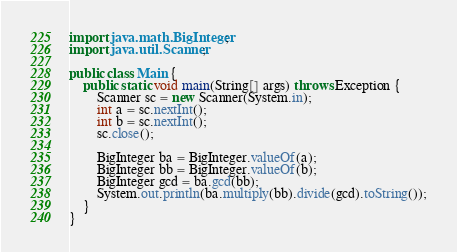Convert code to text. <code><loc_0><loc_0><loc_500><loc_500><_Java_>import java.math.BigInteger;
import java.util.Scanner;

public class Main {
	public static void main(String[] args) throws Exception {
		Scanner sc = new Scanner(System.in);
		int a = sc.nextInt();
		int b = sc.nextInt();
		sc.close();

		BigInteger ba = BigInteger.valueOf(a);
		BigInteger bb = BigInteger.valueOf(b);
		BigInteger gcd = ba.gcd(bb);
		System.out.println(ba.multiply(bb).divide(gcd).toString());
	}
}
</code> 